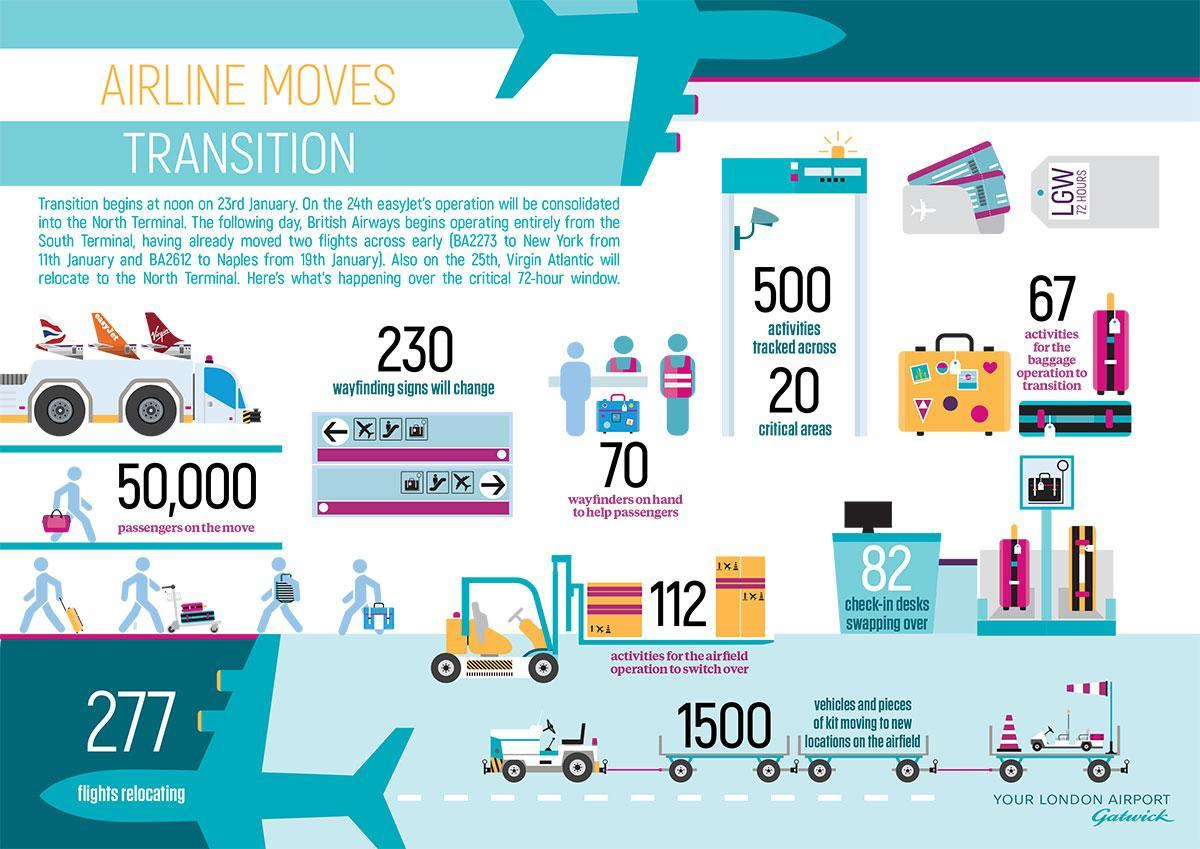How many flights will be relocating?
Answer the question with a short phrase. 277 How many check-in desks are swapping over over the 72-hour window? 82 Which airlines will move to the North terminal? Virgin Atlantic How many wayfinders will be there to help passengers over the critical 72-hour window? 70 